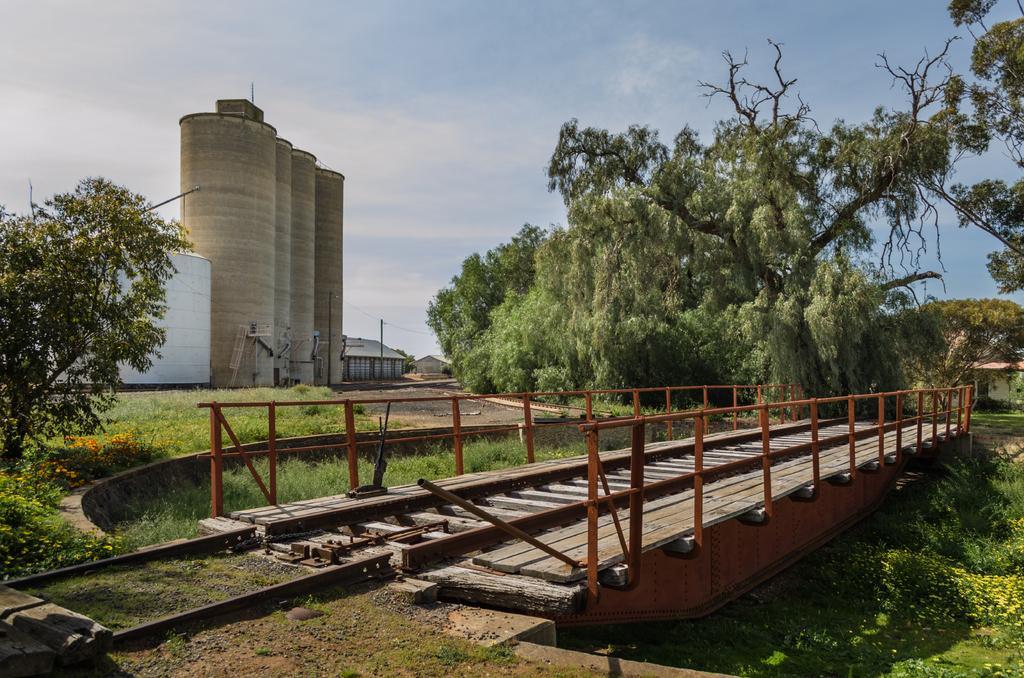Could you give a brief overview of what you see in this image? We can see bridge, grass, plants, flowers and trees. In the background we can see containers, shed, poles and sky. 